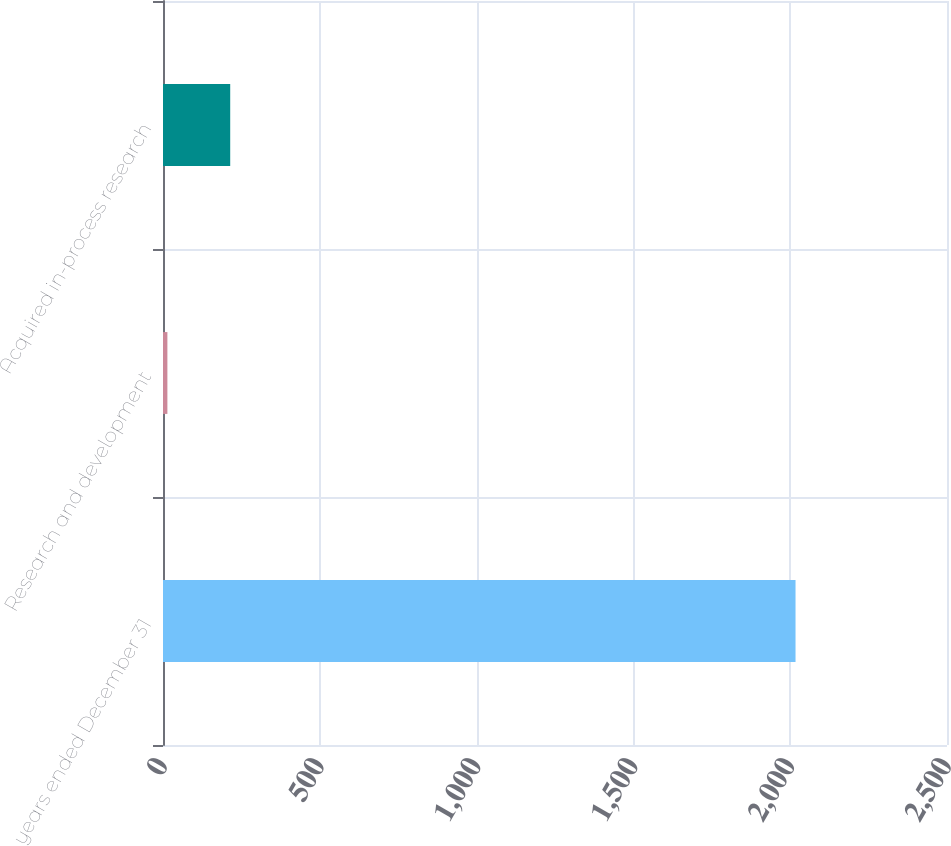<chart> <loc_0><loc_0><loc_500><loc_500><bar_chart><fcel>years ended December 31<fcel>Research and development<fcel>Acquired in-process research<nl><fcel>2017<fcel>14<fcel>214.3<nl></chart> 